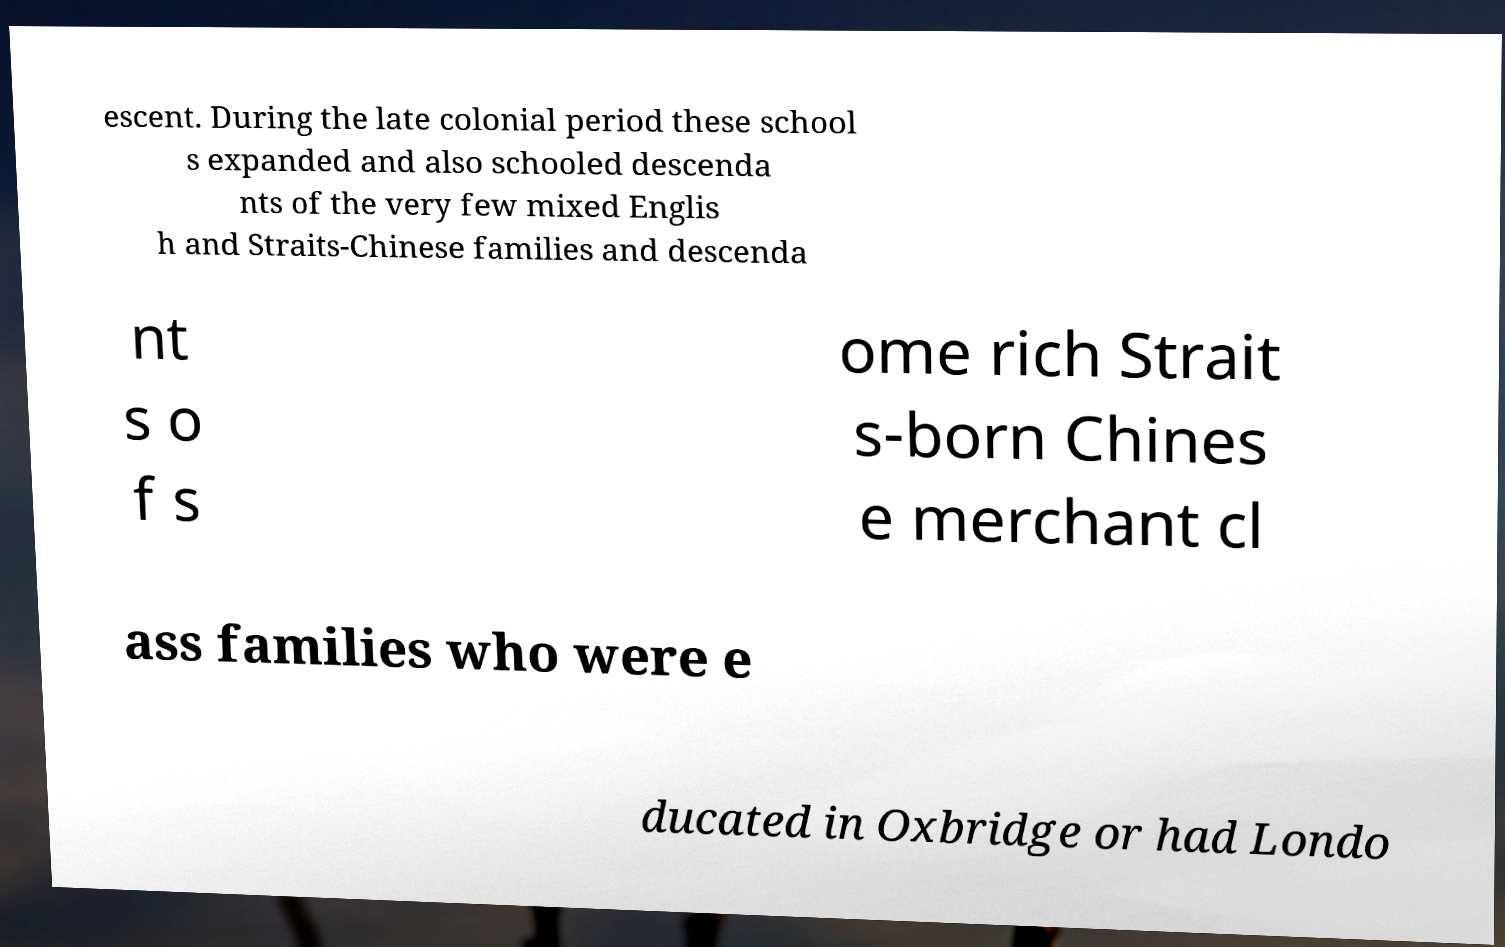There's text embedded in this image that I need extracted. Can you transcribe it verbatim? escent. During the late colonial period these school s expanded and also schooled descenda nts of the very few mixed Englis h and Straits-Chinese families and descenda nt s o f s ome rich Strait s-born Chines e merchant cl ass families who were e ducated in Oxbridge or had Londo 